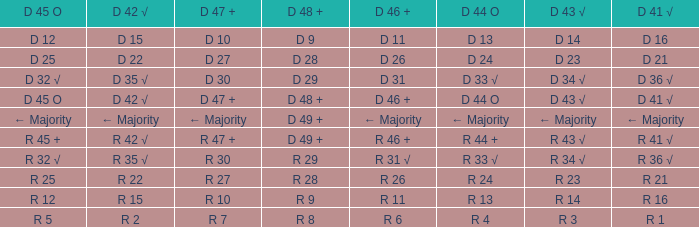What is the value of D 47 + when the value of D 44 O is r 24? R 27. 